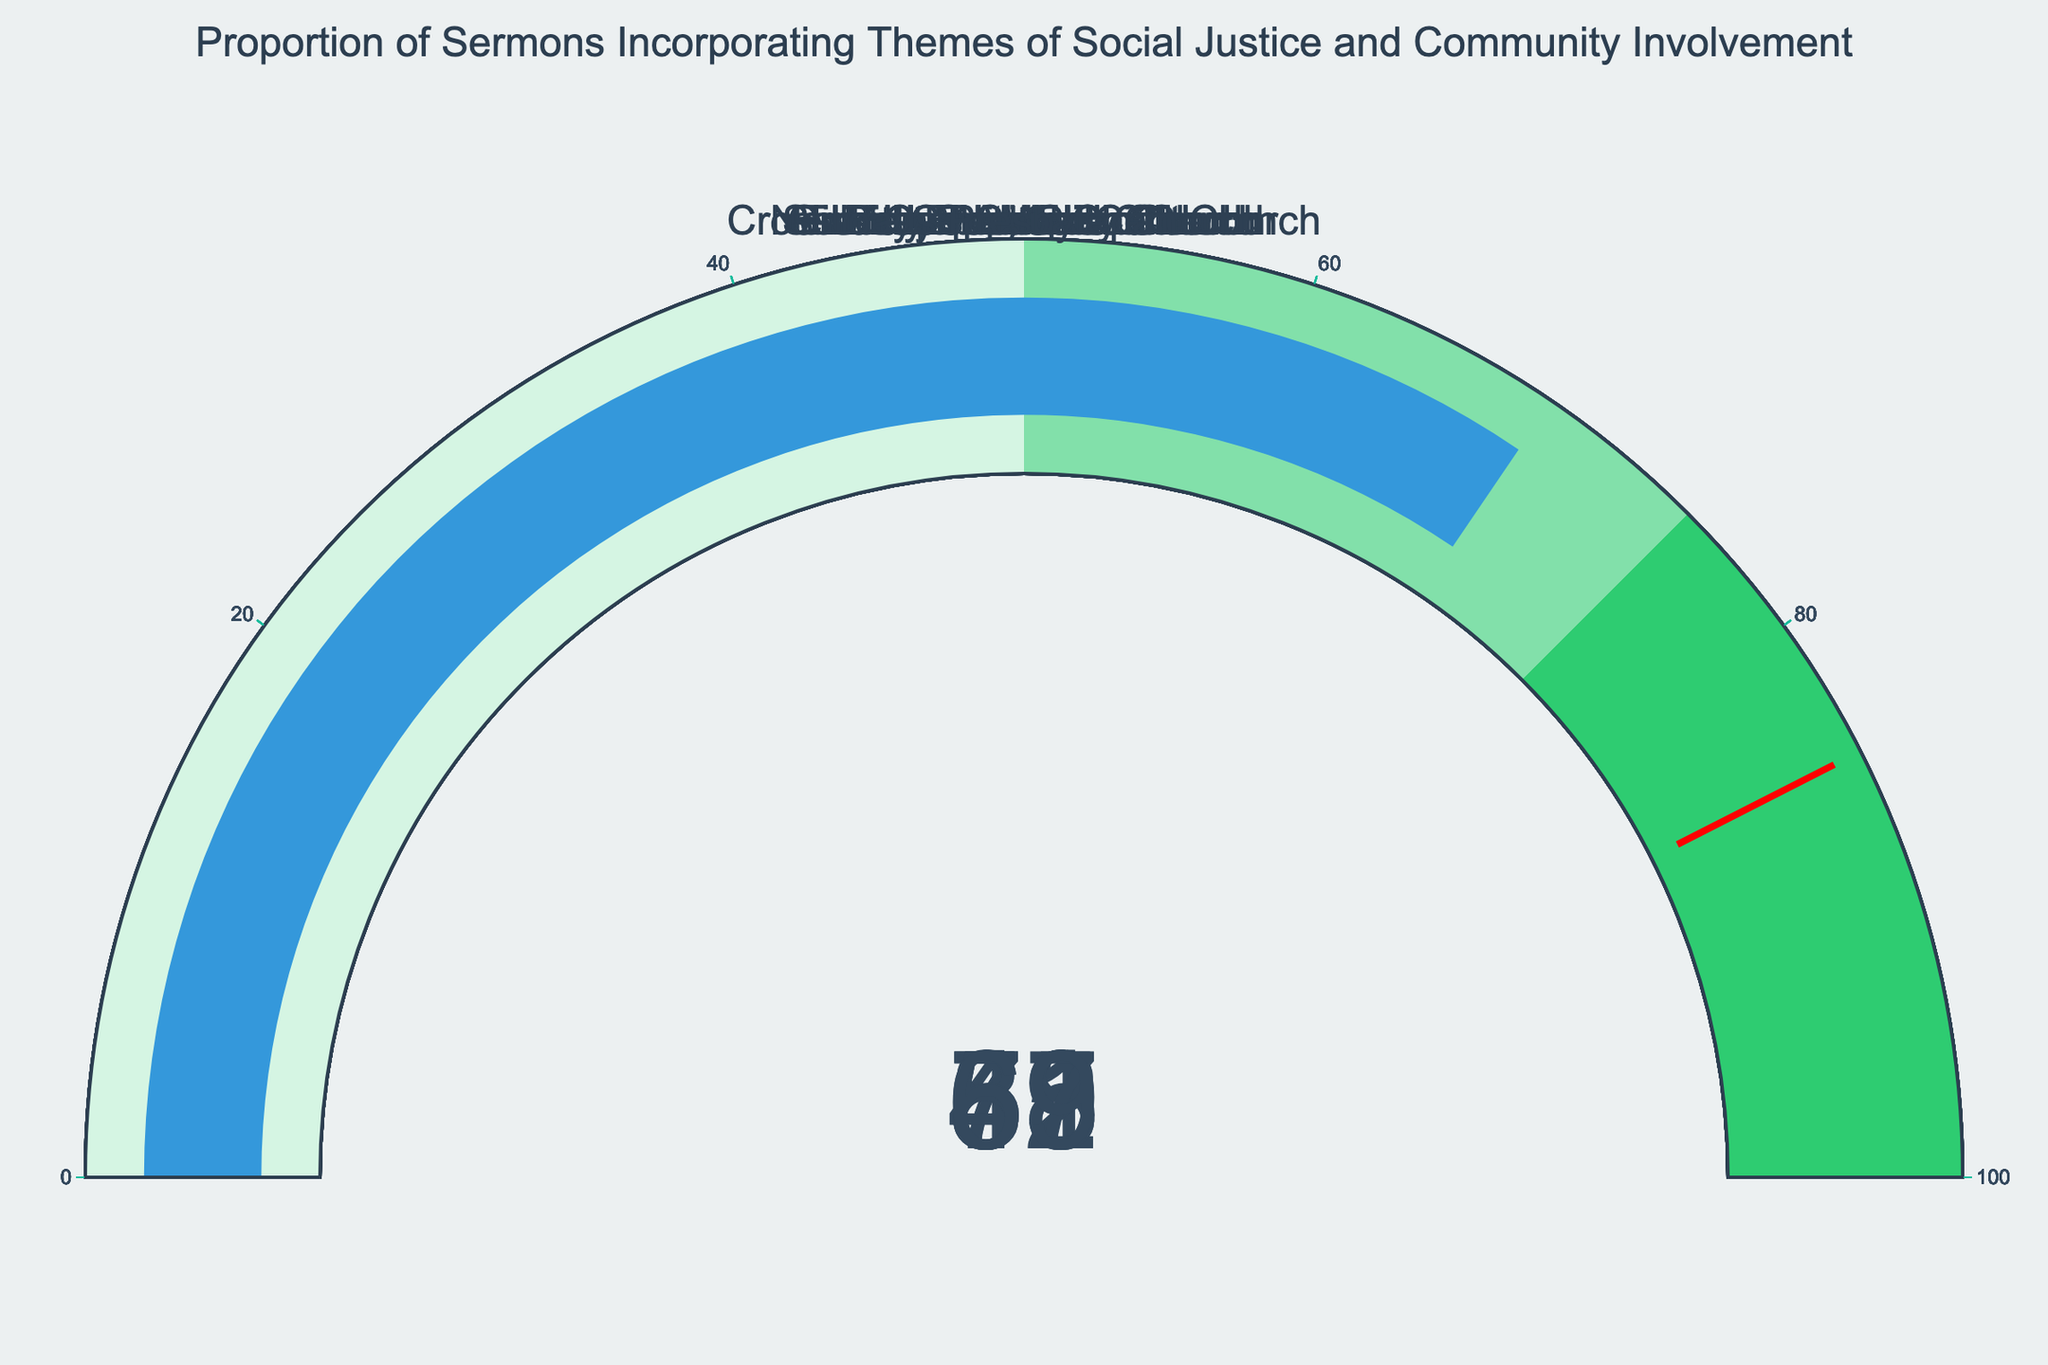How many churches are included in the gauge chart? Count the number of gauges displayed. Each gauge represents one church.
Answer: 10 Which church has the highest proportion of sermons incorporating themes of social justice and community involvement? Look for the gauge with the highest percentage value.
Answer: Bethel AME Church What is the percentage value for Grace Community Church? Find the gauge labeled Grace Community Church and note the displayed percentage.
Answer: 59% What is the average proportion of sermons incorporating themes of social justice and community involvement across all churches? Sum all the percentage values from each gauge and divide by the number of churches (10). Calculation: (65+78+52+71+59+43+82+88+57+69) / 10 = 664 / 10 = 66.4
Answer: 66.4% How many churches have a proportion of sermons incorporating themes of social justice and community involvement between 50% and 75%? Count the number of gauges that fall within the 50–75% range based on their percentage values.
Answer: 6 Which church has the lowest proportion of sermons incorporating themes of social justice and community involvement? Find the gauge with the lowest percentage value.
Answer: Calvary Chapel How does the proportion for First Baptist Church compare to Trinity Episcopal Church? Compare the percentage values for First Baptist Church (65%) and Trinity Episcopal Church (82%).
Answer: First Baptist Church is lower Is the threshold of 85% exceeded by any church? Check if any gauge shows a value above 85%. Bethel AME Church (88%) exceeds this threshold.
Answer: Yes What is the median proportion value of sermons incorporating themes of social justice and community involvement? Sort the values and find the middle value. The sorted values are 43, 52, 57, 59, 65, 69, 71, 78, 82, 88. The median is (65+69)/2 = 67.
Answer: 67% 